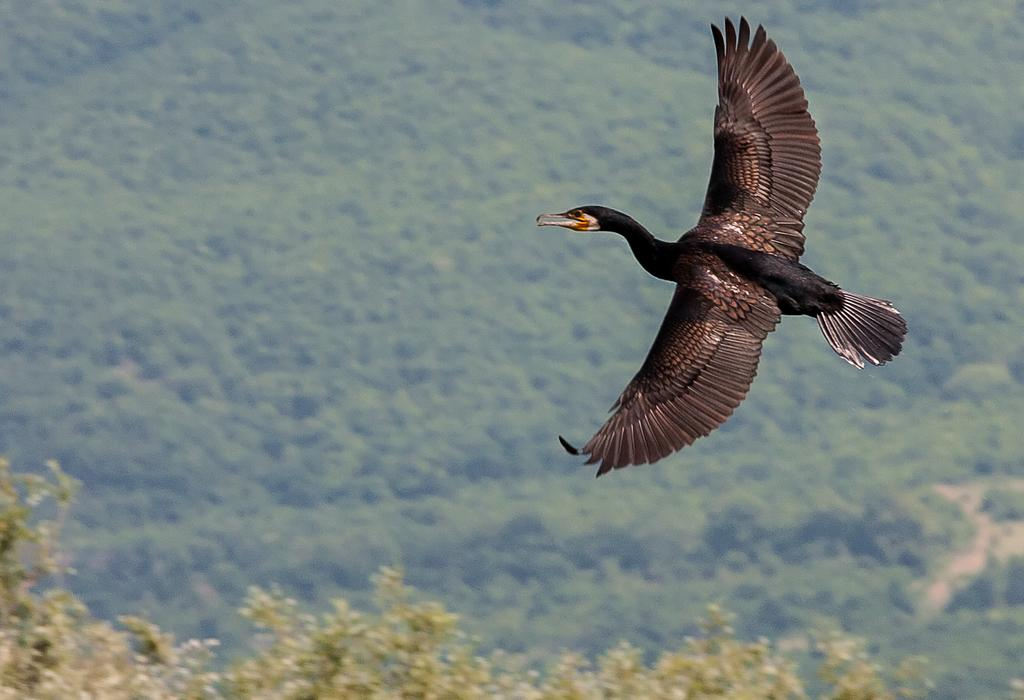What type of bird can be seen in the image? There is a black color bird in the image. What is the bird doing in the image? The bird is flying in the air. What can be seen in the background of the image? There are trees visible in the background of the image. What type of humor can be seen in the bird's expression in the image? The bird's expression cannot be determined from the image, and there is no humor present. 